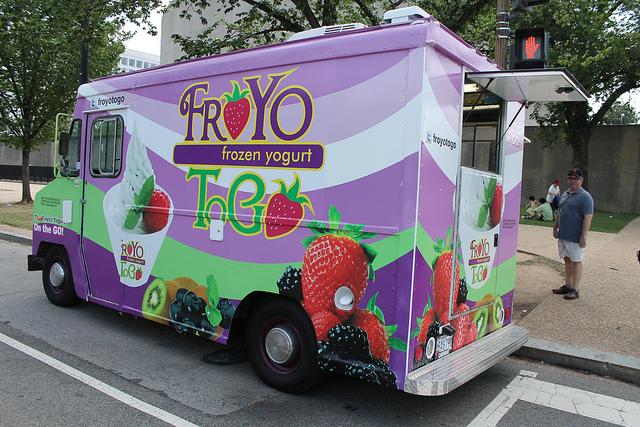What fruit is seen in the cup on the truck? strawberry 